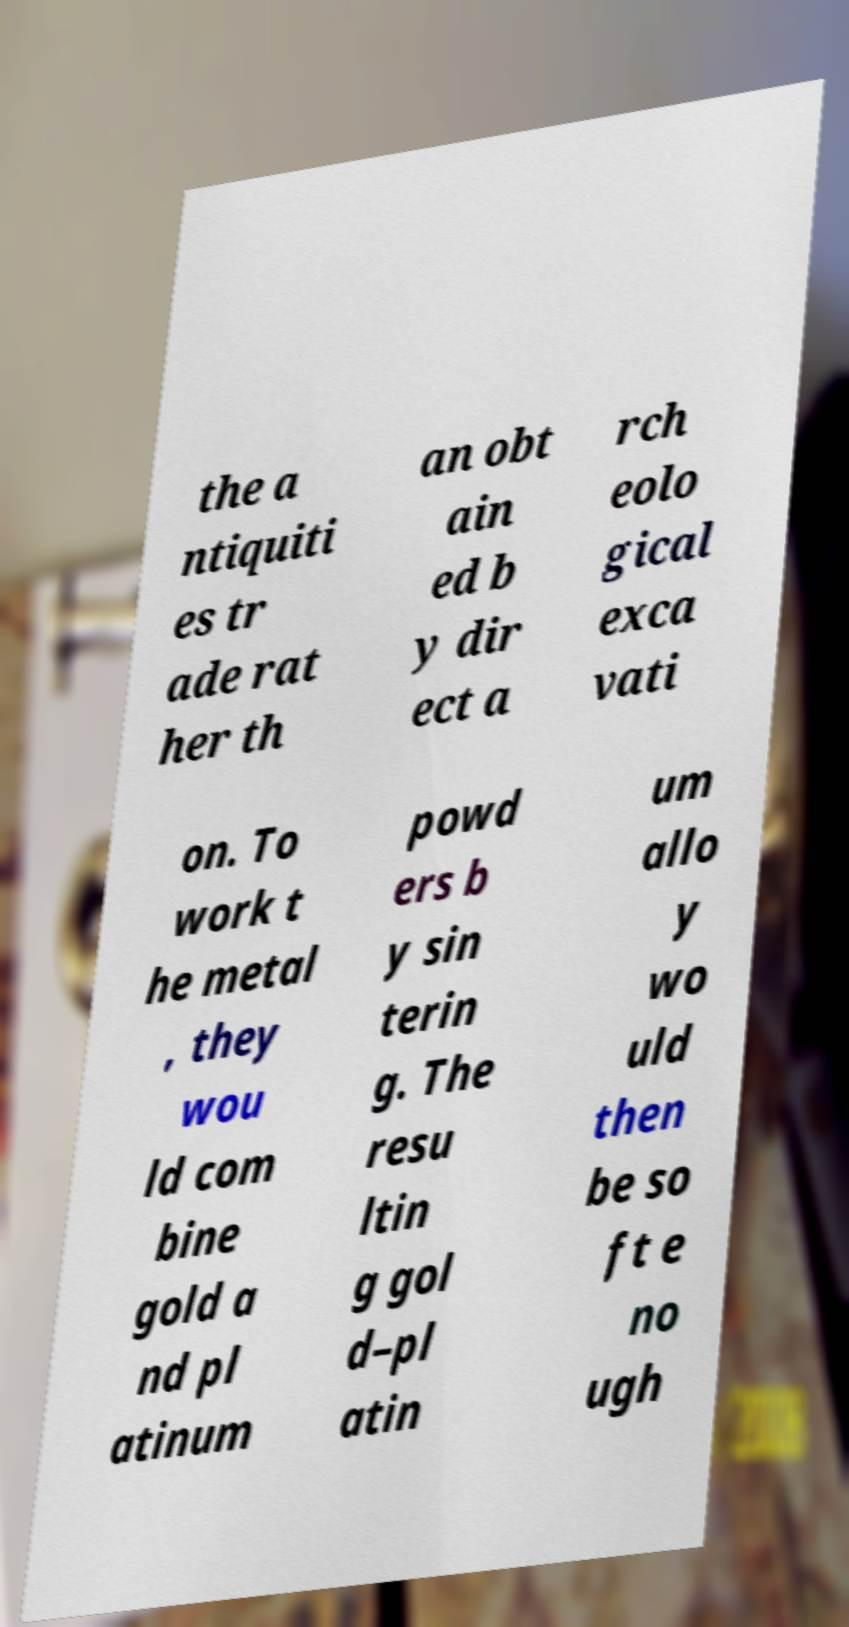Please read and relay the text visible in this image. What does it say? the a ntiquiti es tr ade rat her th an obt ain ed b y dir ect a rch eolo gical exca vati on. To work t he metal , they wou ld com bine gold a nd pl atinum powd ers b y sin terin g. The resu ltin g gol d–pl atin um allo y wo uld then be so ft e no ugh 